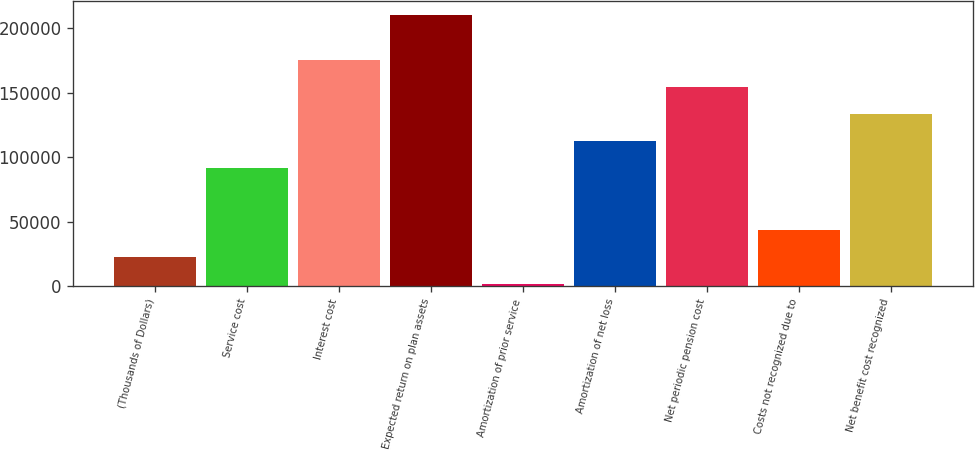<chart> <loc_0><loc_0><loc_500><loc_500><bar_chart><fcel>(Thousands of Dollars)<fcel>Service cost<fcel>Interest cost<fcel>Expected return on plan assets<fcel>Amortization of prior service<fcel>Amortization of net loss<fcel>Net periodic pension cost<fcel>Costs not recognized due to<fcel>Net benefit cost recognized<nl><fcel>22757<fcel>91739<fcel>175091<fcel>210299<fcel>1919<fcel>112577<fcel>154253<fcel>43595<fcel>133415<nl></chart> 